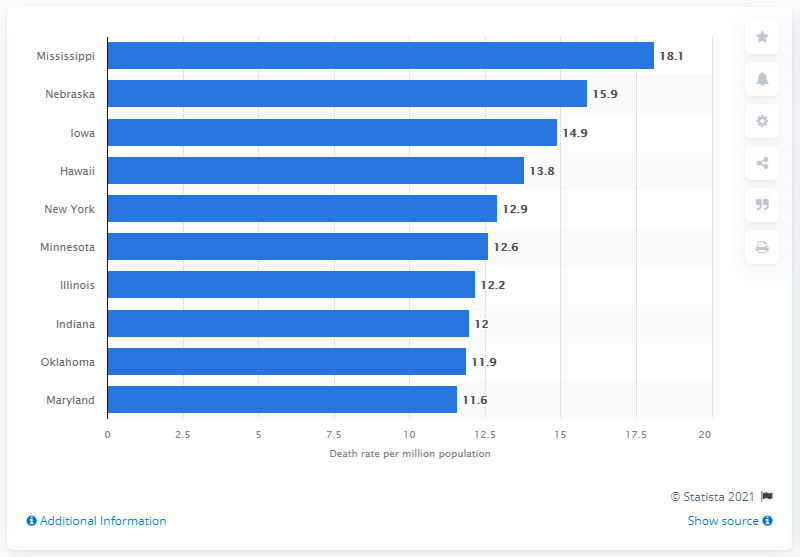Identify some key points in this picture. The rate of deaths due to asthma in Nebraska was 15.9%. In 2019, the population of Mississippi was estimated to be 18.1 per million. 